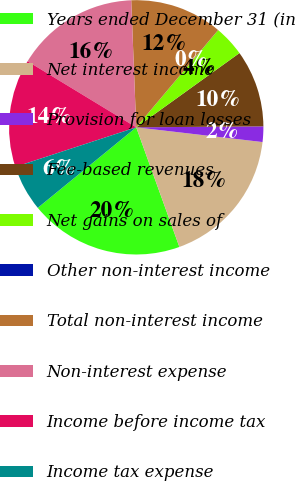Convert chart. <chart><loc_0><loc_0><loc_500><loc_500><pie_chart><fcel>Years ended December 31 (in<fcel>Net interest income<fcel>Provision for loan losses<fcel>Fee-based revenues<fcel>Net gains on sales of<fcel>Other non-interest income<fcel>Total non-interest income<fcel>Non-interest expense<fcel>Income before income tax<fcel>Income tax expense<nl><fcel>19.6%<fcel>17.64%<fcel>1.97%<fcel>9.8%<fcel>3.93%<fcel>0.01%<fcel>11.76%<fcel>15.68%<fcel>13.72%<fcel>5.88%<nl></chart> 